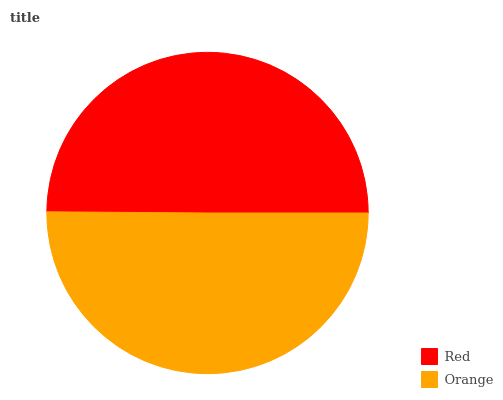Is Red the minimum?
Answer yes or no. Yes. Is Orange the maximum?
Answer yes or no. Yes. Is Orange the minimum?
Answer yes or no. No. Is Orange greater than Red?
Answer yes or no. Yes. Is Red less than Orange?
Answer yes or no. Yes. Is Red greater than Orange?
Answer yes or no. No. Is Orange less than Red?
Answer yes or no. No. Is Orange the high median?
Answer yes or no. Yes. Is Red the low median?
Answer yes or no. Yes. Is Red the high median?
Answer yes or no. No. Is Orange the low median?
Answer yes or no. No. 